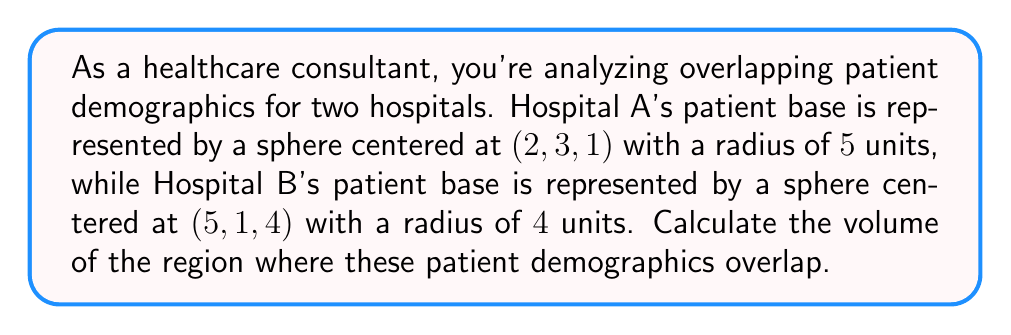Can you answer this question? To solve this problem, we need to calculate the volume of intersection between two spheres. Let's approach this step-by-step:

1) First, we need to find the distance between the centers of the two spheres:

   $$d = \sqrt{(5-2)^2 + (1-3)^2 + (4-1)^2} = \sqrt{3^2 + (-2)^2 + 3^2} = \sqrt{26}$$

2) Now, we can use the formula for the volume of intersection of two spheres:

   $$V = \frac{\pi(R_1 + R_2 - d)^2(d^2 + 2d(R_1 + R_2) - 3(R_1 - R_2)^2 + 6R_1R_2)}{12d}$$

   Where $R_1$ and $R_2$ are the radii of the spheres, and $d$ is the distance between their centers.

3) Substituting our values:
   $R_1 = 5$, $R_2 = 4$, $d = \sqrt{26}$

4) Let's calculate step by step:

   $$V = \frac{\pi(5 + 4 - \sqrt{26})^2(26 + 2\sqrt{26}(5 + 4) - 3(5 - 4)^2 + 6(5)(4))}{12\sqrt{26}}$$

   $$= \frac{\pi(9 - \sqrt{26})^2(26 + 18\sqrt{26} - 3 + 120)}{12\sqrt{26}}$$

   $$= \frac{\pi(9 - \sqrt{26})^2(143 + 18\sqrt{26})}{12\sqrt{26}}$$

5) This can be simplified further, but for precision, it's best to leave it in this form or calculate numerically.

[asy]
import three;

currentprojection = perspective(6,3,2);
real R1 = 5, R2 = 4;
triple c1 = (2,3,1), c2 = (5,1,4);

draw(sphere(c1, R1), rgb(0.7,0.7,1));
draw(sphere(c2, R2), rgb(1,0.7,0.7));

dot(c1,L="A");
dot(c2,L="B");

draw(c1--c2,dashed);
label("d", (c1+c2)/2, N);
[/asy]
Answer: $$\frac{\pi(9 - \sqrt{26})^2(143 + 18\sqrt{26})}{12\sqrt{26}}$$ cubic units 